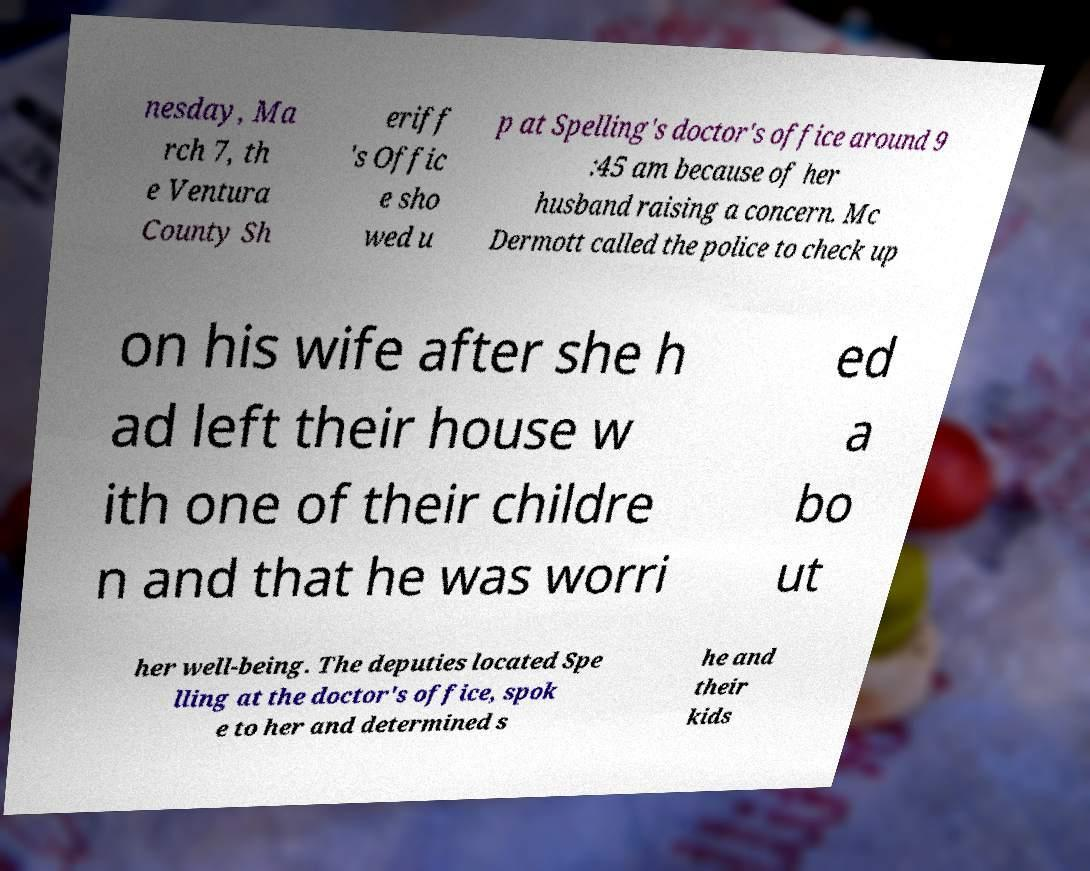Please read and relay the text visible in this image. What does it say? nesday, Ma rch 7, th e Ventura County Sh eriff 's Offic e sho wed u p at Spelling's doctor's office around 9 :45 am because of her husband raising a concern. Mc Dermott called the police to check up on his wife after she h ad left their house w ith one of their childre n and that he was worri ed a bo ut her well-being. The deputies located Spe lling at the doctor's office, spok e to her and determined s he and their kids 